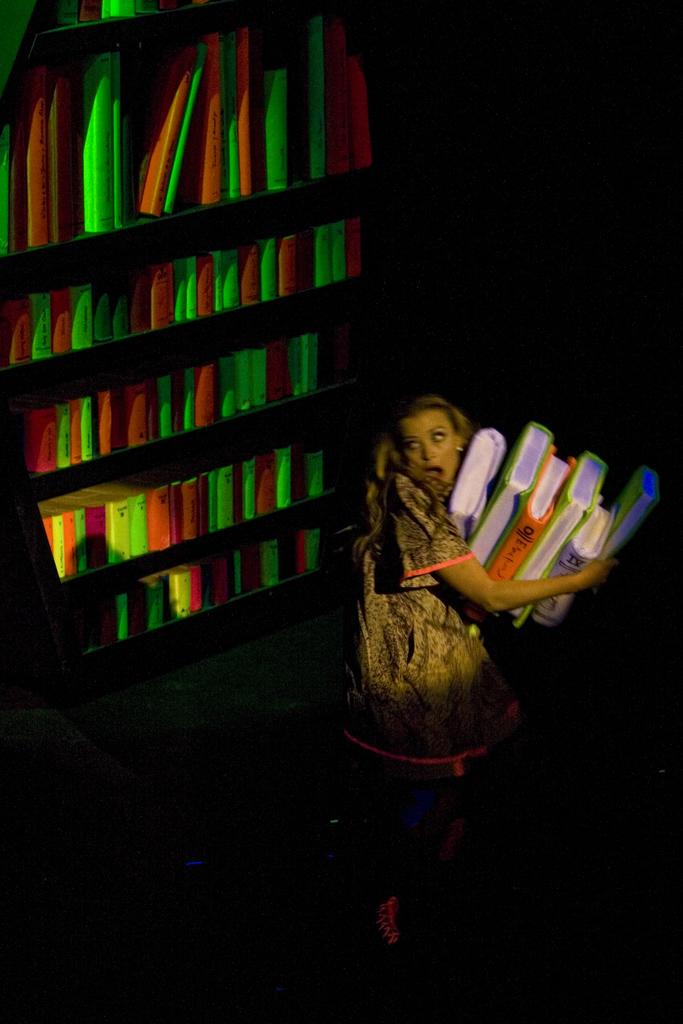Who is present in the image? There is a person in the image. What is the person holding in her hands? The person is holding a few books in her hands. What can be seen on the shelves in the image? There are many books arranged on shelves in the image. What type of cream can be seen on the person's face in the image? There is no cream visible on the person's face in the image. 